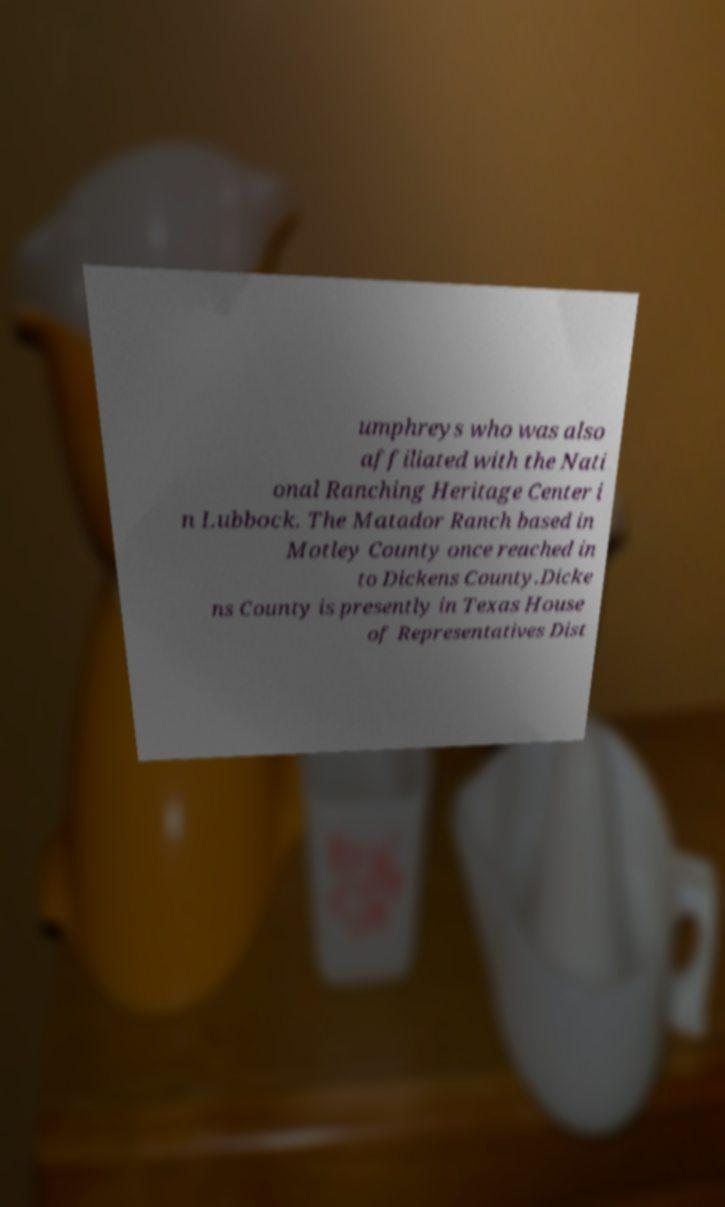Could you extract and type out the text from this image? umphreys who was also affiliated with the Nati onal Ranching Heritage Center i n Lubbock. The Matador Ranch based in Motley County once reached in to Dickens County.Dicke ns County is presently in Texas House of Representatives Dist 